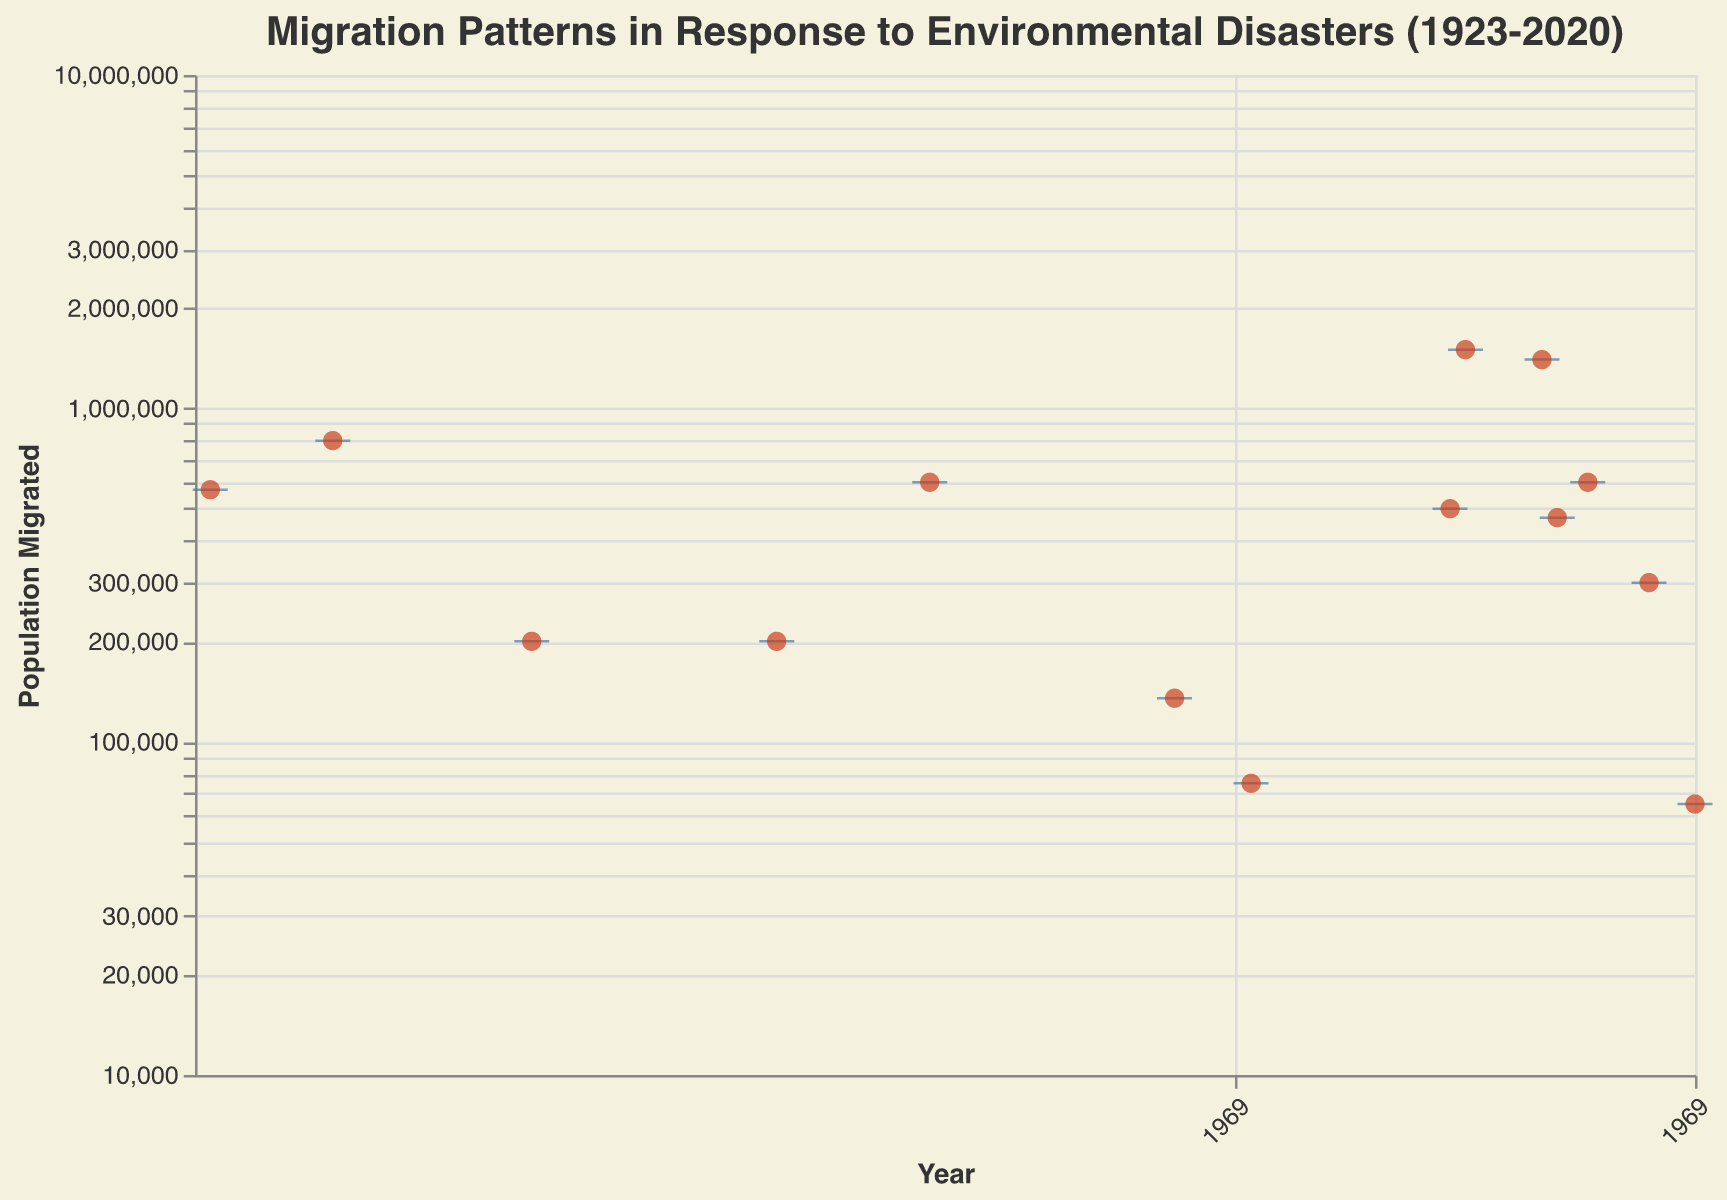What's the title of the plot? The title is usually displayed at the top of the plot or graph. In this case, the title is "Migration Patterns in Response to Environmental Disasters (1923-2020)".
Answer: Migration Patterns in Response to Environmental Disasters (1923-2020) What does the y-axis represent? The y-axis label provides information about what is being measured on the vertical scale. Here, it represents "Population Migrated".
Answer: Population Migrated Which disaster resulted in the highest migration? To find this, look for the highest scatter point on the y-axis and check the tooltip or label of that point. The highest point corresponds to the "Haiti Earthquake" in 2010 with a migration of 1,400,000 people.
Answer: Haiti Earthquake What is the median value of the population migrated? To determine the median value, look for the median line inside the box plot, which is usually a distinct line within the box. The median line's location and the tooltip provide this information. Here, it shows approximately 265,000 (slightly varies due to logarithmic scale interpretation).
Answer: ~265,000 Which countries experienced environmental disasters that led to over 1 million people migrating? To answer this, identify the scatter points above the 1 million mark on the y-axis and refer to their associated tooltips. Countries are the United States (Hurricane Katrina) and Haiti (Haiti Earthquake).
Answer: United States and Haiti Which year had the lowest migration due to environmental disasters? Look for the scatter point closest to the bottom of the y-axis. The tooltip of this point shows that the year is 2020 and the disaster is "Black Summer Bushfires" in Australia with 65,000 people migrating.
Answer: 2020 How many unique environmental disasters are represented in the plot? Count the number of different disaster names in the tooltips or the data list. There are 14 unique environmental disasters listed in the data.
Answer: 14 Compare the population migrations of the Great Kanto Earthquake and the Tohoku Earthquake and Tsunami. Which one caused more migration? Locate the scatter points for both events and compare their y-axis values. The Great Kanto Earthquake (1923) caused a migration of 570,000 people, while the Tohoku Earthquake and Tsunami (2011) caused a migration of 470,000 people.
Answer: Great Kanto Earthquake What is the primary reason for migration due to the Chernobyl Disaster in 1986? Refer to the tooltip for the scatter point of the Chernobyl Disaster in 1986. It indicates that the primary reason for migration was "Radiation contamination and long-term health risks".
Answer: Radiation contamination and long-term health risks How does the log scale of the y-axis affect the interpretation of population migrated values? The log scale compresses the larger values and expands the smaller values on the y-axis, making it easier to compare populations of different magnitudes but harder to visually interpret exact values.
Answer: Compresses large values and expands small values 